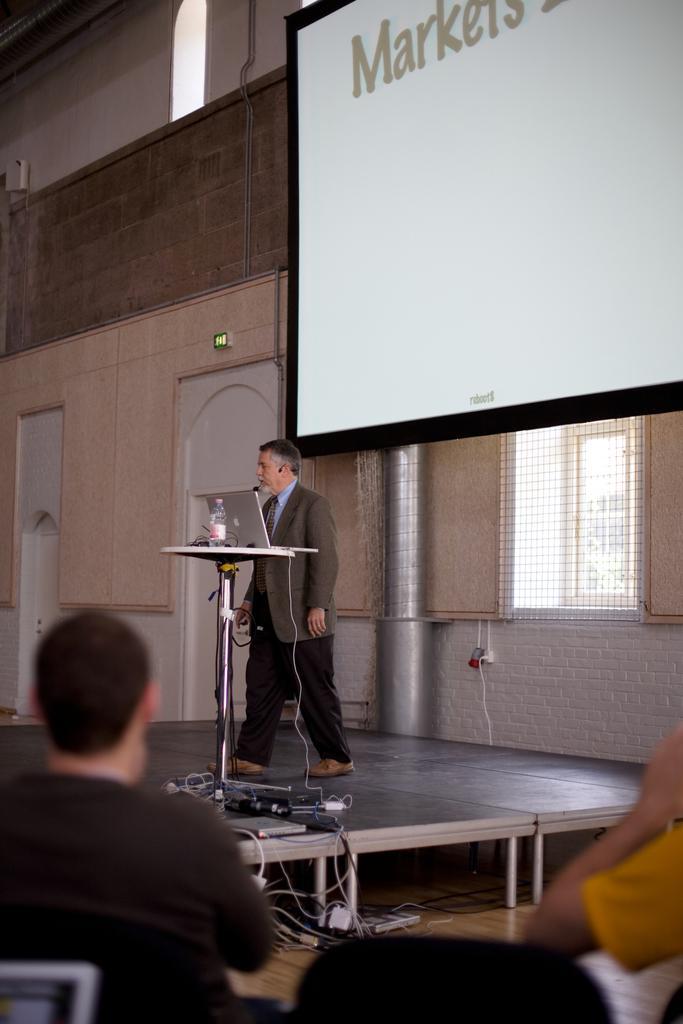Please provide a concise description of this image. This image consists of a man standing on the dais. He is wearing a suit. In front of him, there is a table on which there is a bottle and a laptop. In the background, we can see a wall along with windows and doors. On the right, there is a projector screen. At the bottom, there is a man sitting. He is wearing a black T-shirt. 